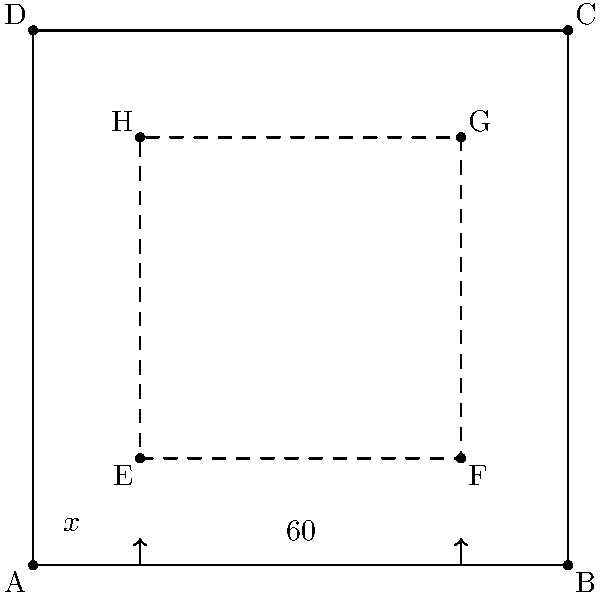In a UI design, you need to calculate the consistent spacing between elements. The outer container is a square with sides of 100 pixels. The inner container is also a square, with its corners 20 pixels away from the outer container's edges. If the width of a UI element is 60 pixels, what angle $\theta$ should be used to maintain consistent spacing between the element and the inner container's edges? Round your answer to the nearest degree. To solve this problem, we'll follow these steps:

1) First, we need to identify the right triangle formed by the spacing. The base of this triangle is half of the difference between the inner container's width and the UI element's width.

   Inner container width = 100 - 2(20) = 60 pixels
   UI element width = 60 pixels
   Base of triangle = (60 - 60) / 2 = 0 pixels

2) The height of the triangle is the spacing we're looking for, which is 20 pixels (the distance from the outer container's edge to the inner container's edge).

3) Now we have a right triangle with:
   - Adjacent side (base) = 0 pixels
   - Opposite side (height) = 20 pixels

4) To find the angle, we use the arctangent function:

   $$\theta = \arctan(\frac{\text{opposite}}{\text{adjacent}})$$

5) However, since the adjacent side is 0, this results in an undefined value (division by zero).

6) In this case, when the adjacent side is 0 and the opposite side is positive, the angle is always 90 degrees. This makes sense geometrically, as the UI element exactly fits the width of the inner container, leaving only vertical space.

Therefore, the angle $\theta$ needed to maintain consistent spacing is 90 degrees.
Answer: 90° 